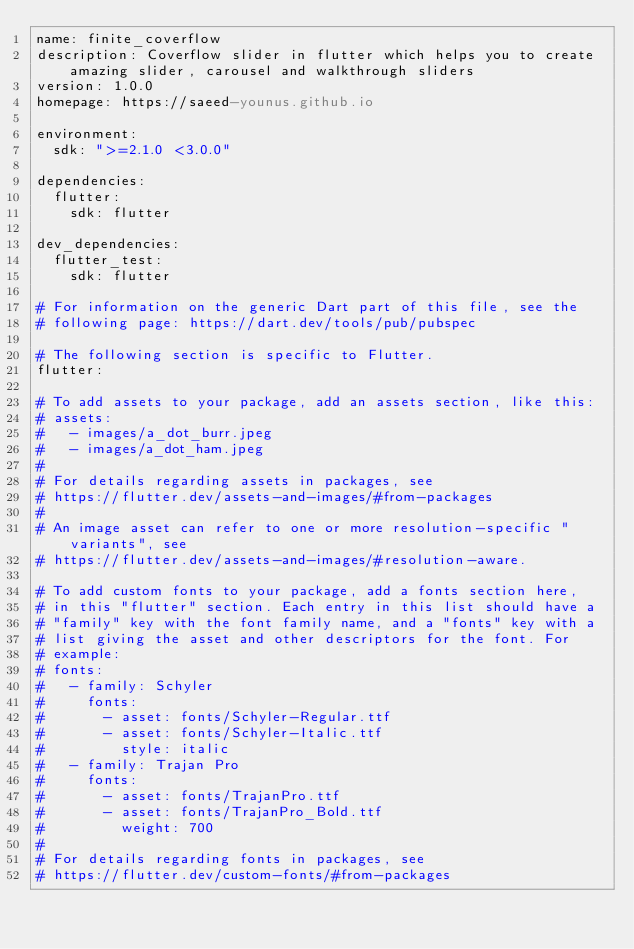<code> <loc_0><loc_0><loc_500><loc_500><_YAML_>name: finite_coverflow
description: Coverflow slider in flutter which helps you to create amazing slider, carousel and walkthrough sliders
version: 1.0.0
homepage: https://saeed-younus.github.io

environment:
  sdk: ">=2.1.0 <3.0.0"

dependencies:
  flutter:
    sdk: flutter

dev_dependencies:
  flutter_test:
    sdk: flutter

# For information on the generic Dart part of this file, see the
# following page: https://dart.dev/tools/pub/pubspec

# The following section is specific to Flutter.
flutter:

# To add assets to your package, add an assets section, like this:
# assets:
#   - images/a_dot_burr.jpeg
#   - images/a_dot_ham.jpeg
#
# For details regarding assets in packages, see
# https://flutter.dev/assets-and-images/#from-packages
#
# An image asset can refer to one or more resolution-specific "variants", see
# https://flutter.dev/assets-and-images/#resolution-aware.

# To add custom fonts to your package, add a fonts section here,
# in this "flutter" section. Each entry in this list should have a
# "family" key with the font family name, and a "fonts" key with a
# list giving the asset and other descriptors for the font. For
# example:
# fonts:
#   - family: Schyler
#     fonts:
#       - asset: fonts/Schyler-Regular.ttf
#       - asset: fonts/Schyler-Italic.ttf
#         style: italic
#   - family: Trajan Pro
#     fonts:
#       - asset: fonts/TrajanPro.ttf
#       - asset: fonts/TrajanPro_Bold.ttf
#         weight: 700
#
# For details regarding fonts in packages, see
# https://flutter.dev/custom-fonts/#from-packages
</code> 